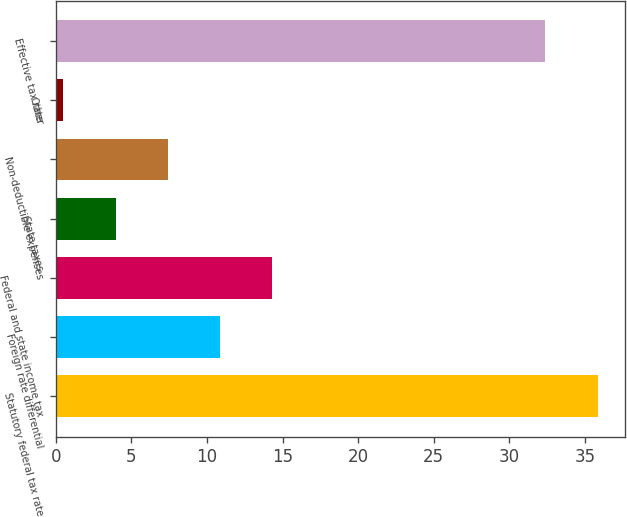Convert chart to OTSL. <chart><loc_0><loc_0><loc_500><loc_500><bar_chart><fcel>Statutory federal tax rate<fcel>Foreign rate differential<fcel>Federal and state income tax<fcel>State taxes<fcel>Non-deductible expenses<fcel>Other<fcel>Effective tax rate<nl><fcel>35.85<fcel>10.85<fcel>14.3<fcel>3.95<fcel>7.4<fcel>0.5<fcel>32.4<nl></chart> 